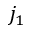<formula> <loc_0><loc_0><loc_500><loc_500>j _ { 1 }</formula> 